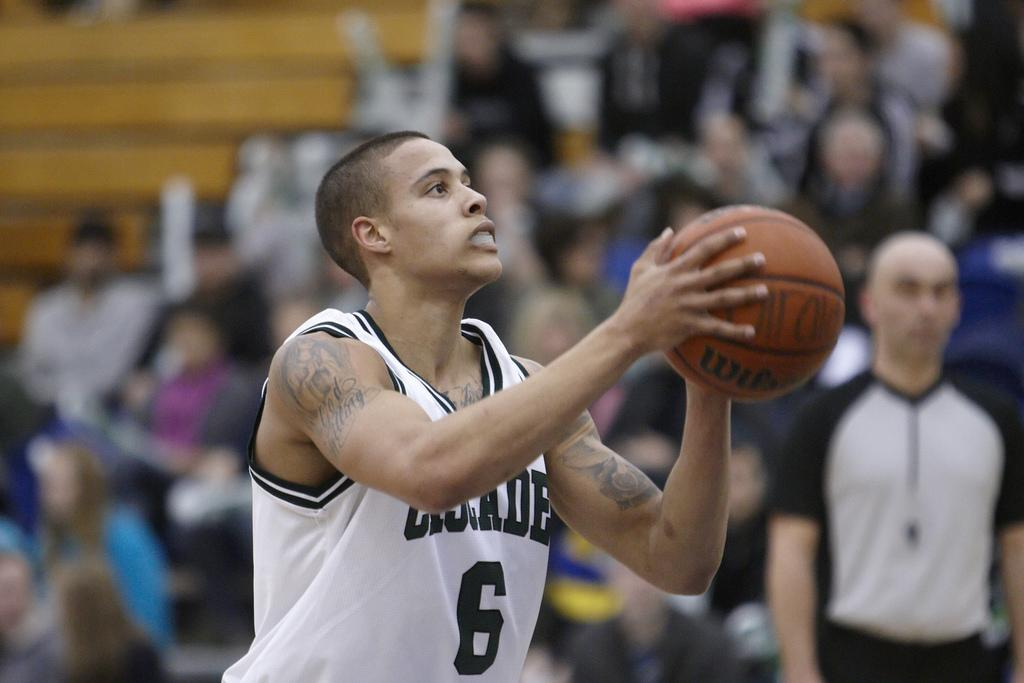Who or what is the main subject in the image? There is a person in the image. What is the person holding in the image? The person is holding a ball. Can you describe the background of the image? The background of the image is blurred. Are there any other people visible in the image? Yes, there are people visible in the image. What type of holiday is being celebrated in the image? There is no indication of a holiday being celebrated in the image. Can you see a pig in the image? No, there is no pig present in the image. 